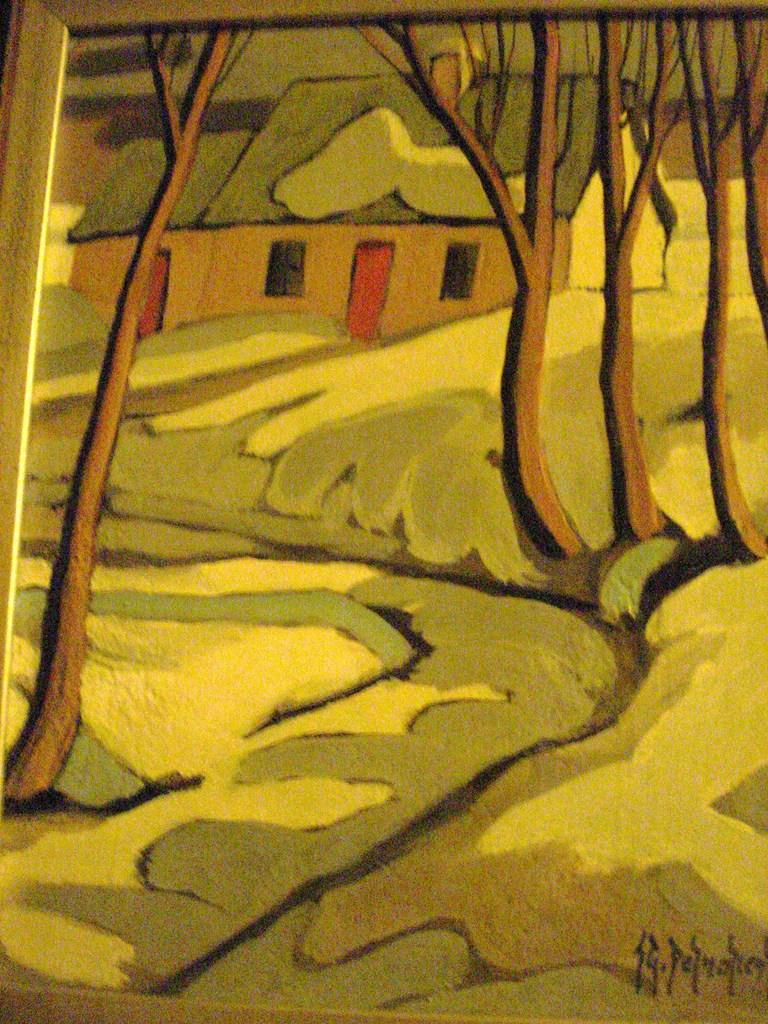What is the main subject of the image? The main subject of the image is a frame. What is depicted inside the frame? The frame contains a house, a tree branch, and grass. Is there any text or marking in the image? Yes, there is a signature in the image. How many chickens are running around the house in the image? There are no chickens present in the image; it only contains a house, a tree branch, and grass within the frame. What type of farmer is shown tending to the crops in the image? There is no farmer present in the image; it only contains a house, a tree branch, and grass within the frame. 